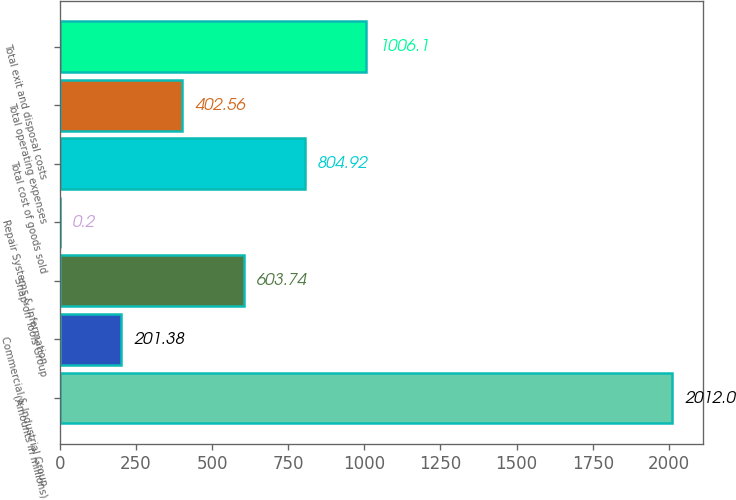Convert chart. <chart><loc_0><loc_0><loc_500><loc_500><bar_chart><fcel>(Amounts in millions)<fcel>Commercial & Industrial Group<fcel>Snap-on Tools Group<fcel>Repair Systems & Information<fcel>Total cost of goods sold<fcel>Total operating expenses<fcel>Total exit and disposal costs<nl><fcel>2012<fcel>201.38<fcel>603.74<fcel>0.2<fcel>804.92<fcel>402.56<fcel>1006.1<nl></chart> 